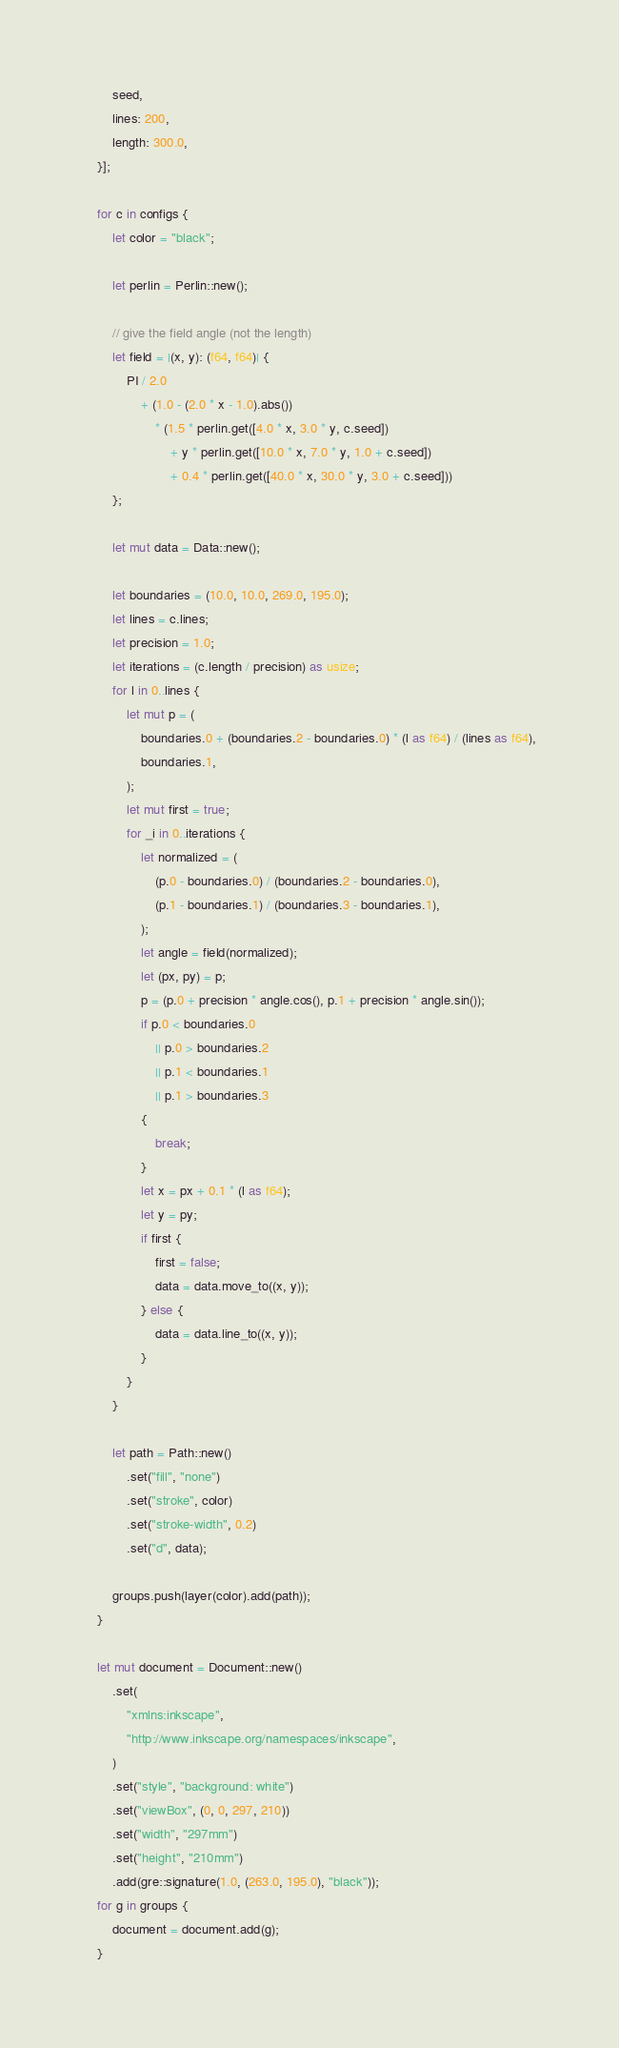<code> <loc_0><loc_0><loc_500><loc_500><_Rust_>        seed,
        lines: 200,
        length: 300.0,
    }];

    for c in configs {
        let color = "black";

        let perlin = Perlin::new();

        // give the field angle (not the length)
        let field = |(x, y): (f64, f64)| {
            PI / 2.0
                + (1.0 - (2.0 * x - 1.0).abs())
                    * (1.5 * perlin.get([4.0 * x, 3.0 * y, c.seed])
                        + y * perlin.get([10.0 * x, 7.0 * y, 1.0 + c.seed])
                        + 0.4 * perlin.get([40.0 * x, 30.0 * y, 3.0 + c.seed]))
        };

        let mut data = Data::new();

        let boundaries = (10.0, 10.0, 269.0, 195.0);
        let lines = c.lines;
        let precision = 1.0;
        let iterations = (c.length / precision) as usize;
        for l in 0..lines {
            let mut p = (
                boundaries.0 + (boundaries.2 - boundaries.0) * (l as f64) / (lines as f64),
                boundaries.1,
            );
            let mut first = true;
            for _i in 0..iterations {
                let normalized = (
                    (p.0 - boundaries.0) / (boundaries.2 - boundaries.0),
                    (p.1 - boundaries.1) / (boundaries.3 - boundaries.1),
                );
                let angle = field(normalized);
                let (px, py) = p;
                p = (p.0 + precision * angle.cos(), p.1 + precision * angle.sin());
                if p.0 < boundaries.0
                    || p.0 > boundaries.2
                    || p.1 < boundaries.1
                    || p.1 > boundaries.3
                {
                    break;
                }
                let x = px + 0.1 * (l as f64);
                let y = py;
                if first {
                    first = false;
                    data = data.move_to((x, y));
                } else {
                    data = data.line_to((x, y));
                }
            }
        }

        let path = Path::new()
            .set("fill", "none")
            .set("stroke", color)
            .set("stroke-width", 0.2)
            .set("d", data);

        groups.push(layer(color).add(path));
    }

    let mut document = Document::new()
        .set(
            "xmlns:inkscape",
            "http://www.inkscape.org/namespaces/inkscape",
        )
        .set("style", "background: white")
        .set("viewBox", (0, 0, 297, 210))
        .set("width", "297mm")
        .set("height", "210mm")
        .add(gre::signature(1.0, (263.0, 195.0), "black"));
    for g in groups {
        document = document.add(g);
    }
</code> 